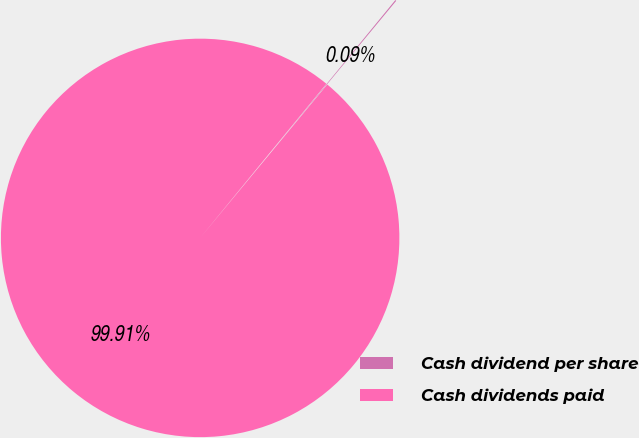<chart> <loc_0><loc_0><loc_500><loc_500><pie_chart><fcel>Cash dividend per share<fcel>Cash dividends paid<nl><fcel>0.09%<fcel>99.91%<nl></chart> 